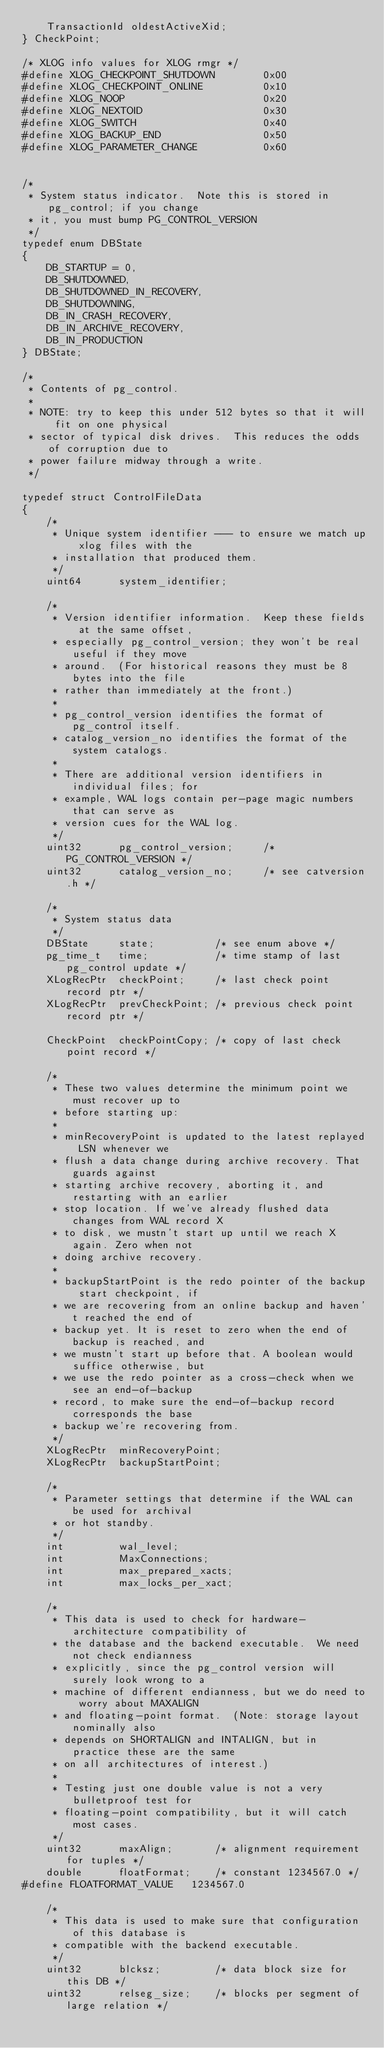<code> <loc_0><loc_0><loc_500><loc_500><_C_>	TransactionId oldestActiveXid;
} CheckPoint;

/* XLOG info values for XLOG rmgr */
#define XLOG_CHECKPOINT_SHUTDOWN		0x00
#define XLOG_CHECKPOINT_ONLINE			0x10
#define XLOG_NOOP						0x20
#define XLOG_NEXTOID					0x30
#define XLOG_SWITCH						0x40
#define XLOG_BACKUP_END					0x50
#define XLOG_PARAMETER_CHANGE			0x60


/*
 * System status indicator.  Note this is stored in pg_control; if you change
 * it, you must bump PG_CONTROL_VERSION
 */
typedef enum DBState
{
	DB_STARTUP = 0,
	DB_SHUTDOWNED,
	DB_SHUTDOWNED_IN_RECOVERY,
	DB_SHUTDOWNING,
	DB_IN_CRASH_RECOVERY,
	DB_IN_ARCHIVE_RECOVERY,
	DB_IN_PRODUCTION
} DBState;

/*
 * Contents of pg_control.
 *
 * NOTE: try to keep this under 512 bytes so that it will fit on one physical
 * sector of typical disk drives.  This reduces the odds of corruption due to
 * power failure midway through a write.
 */

typedef struct ControlFileData
{
	/*
	 * Unique system identifier --- to ensure we match up xlog files with the
	 * installation that produced them.
	 */
	uint64		system_identifier;

	/*
	 * Version identifier information.	Keep these fields at the same offset,
	 * especially pg_control_version; they won't be real useful if they move
	 * around.	(For historical reasons they must be 8 bytes into the file
	 * rather than immediately at the front.)
	 *
	 * pg_control_version identifies the format of pg_control itself.
	 * catalog_version_no identifies the format of the system catalogs.
	 *
	 * There are additional version identifiers in individual files; for
	 * example, WAL logs contain per-page magic numbers that can serve as
	 * version cues for the WAL log.
	 */
	uint32		pg_control_version;		/* PG_CONTROL_VERSION */
	uint32		catalog_version_no;		/* see catversion.h */

	/*
	 * System status data
	 */
	DBState		state;			/* see enum above */
	pg_time_t	time;			/* time stamp of last pg_control update */
	XLogRecPtr	checkPoint;		/* last check point record ptr */
	XLogRecPtr	prevCheckPoint; /* previous check point record ptr */

	CheckPoint	checkPointCopy; /* copy of last check point record */

	/*
	 * These two values determine the minimum point we must recover up to
	 * before starting up:
	 *
	 * minRecoveryPoint is updated to the latest replayed LSN whenever we
	 * flush a data change during archive recovery. That guards against
	 * starting archive recovery, aborting it, and restarting with an earlier
	 * stop location. If we've already flushed data changes from WAL record X
	 * to disk, we mustn't start up until we reach X again. Zero when not
	 * doing archive recovery.
	 *
	 * backupStartPoint is the redo pointer of the backup start checkpoint, if
	 * we are recovering from an online backup and haven't reached the end of
	 * backup yet. It is reset to zero when the end of backup is reached, and
	 * we mustn't start up before that. A boolean would suffice otherwise, but
	 * we use the redo pointer as a cross-check when we see an end-of-backup
	 * record, to make sure the end-of-backup record corresponds the base
	 * backup we're recovering from.
	 */
	XLogRecPtr	minRecoveryPoint;
	XLogRecPtr	backupStartPoint;

	/*
	 * Parameter settings that determine if the WAL can be used for archival
	 * or hot standby.
	 */
	int			wal_level;
	int			MaxConnections;
	int			max_prepared_xacts;
	int			max_locks_per_xact;

	/*
	 * This data is used to check for hardware-architecture compatibility of
	 * the database and the backend executable.  We need not check endianness
	 * explicitly, since the pg_control version will surely look wrong to a
	 * machine of different endianness, but we do need to worry about MAXALIGN
	 * and floating-point format.  (Note: storage layout nominally also
	 * depends on SHORTALIGN and INTALIGN, but in practice these are the same
	 * on all architectures of interest.)
	 *
	 * Testing just one double value is not a very bulletproof test for
	 * floating-point compatibility, but it will catch most cases.
	 */
	uint32		maxAlign;		/* alignment requirement for tuples */
	double		floatFormat;	/* constant 1234567.0 */
#define FLOATFORMAT_VALUE	1234567.0

	/*
	 * This data is used to make sure that configuration of this database is
	 * compatible with the backend executable.
	 */
	uint32		blcksz;			/* data block size for this DB */
	uint32		relseg_size;	/* blocks per segment of large relation */
</code> 